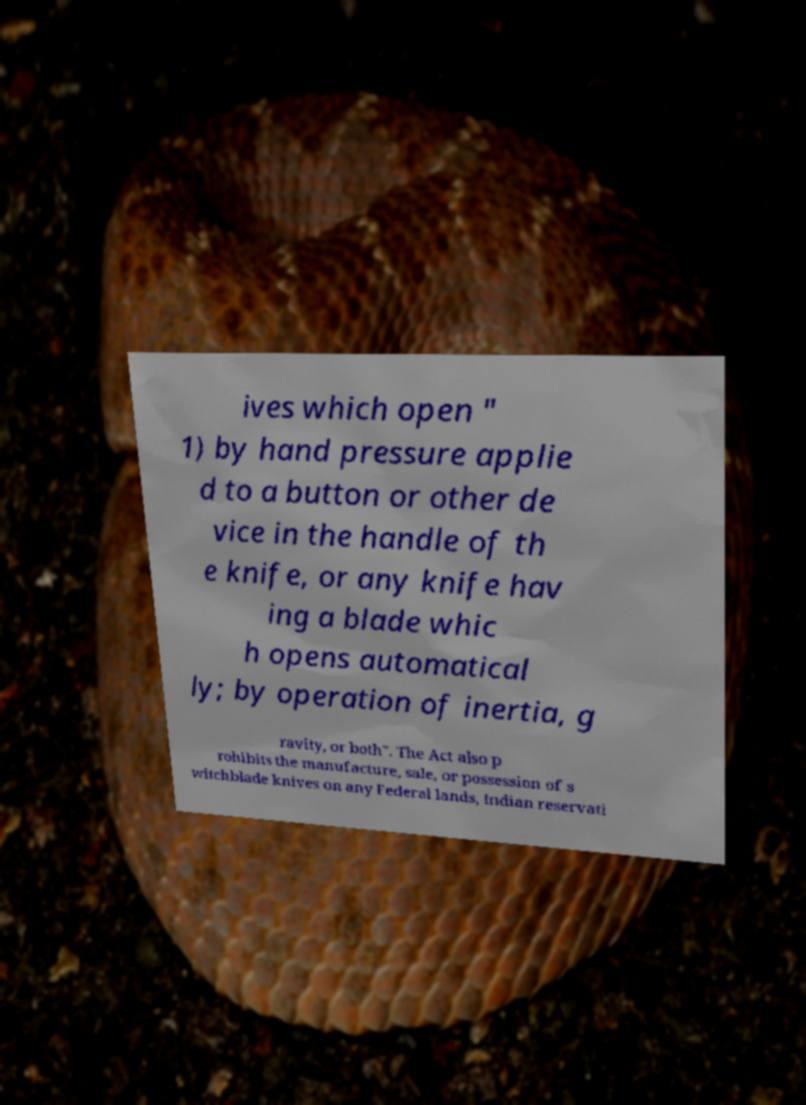I need the written content from this picture converted into text. Can you do that? ives which open " 1) by hand pressure applie d to a button or other de vice in the handle of th e knife, or any knife hav ing a blade whic h opens automatical ly; by operation of inertia, g ravity, or both". The Act also p rohibits the manufacture, sale, or possession of s witchblade knives on any Federal lands, Indian reservati 